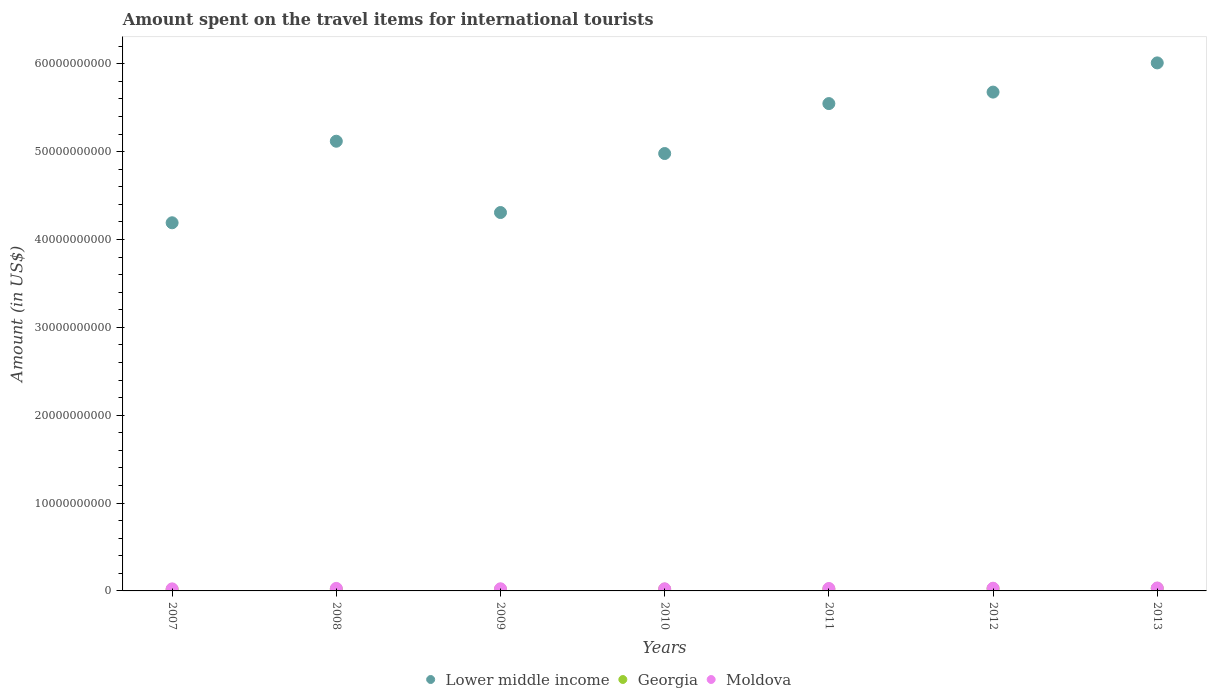How many different coloured dotlines are there?
Provide a short and direct response. 3. What is the amount spent on the travel items for international tourists in Moldova in 2013?
Offer a terse response. 3.34e+08. Across all years, what is the maximum amount spent on the travel items for international tourists in Lower middle income?
Give a very brief answer. 6.01e+1. Across all years, what is the minimum amount spent on the travel items for international tourists in Georgia?
Your answer should be very brief. 1.76e+08. In which year was the amount spent on the travel items for international tourists in Georgia maximum?
Your answer should be compact. 2013. What is the total amount spent on the travel items for international tourists in Moldova in the graph?
Provide a succinct answer. 1.92e+09. What is the difference between the amount spent on the travel items for international tourists in Lower middle income in 2008 and that in 2012?
Make the answer very short. -5.59e+09. What is the difference between the amount spent on the travel items for international tourists in Lower middle income in 2013 and the amount spent on the travel items for international tourists in Moldova in 2012?
Offer a very short reply. 5.98e+1. What is the average amount spent on the travel items for international tourists in Lower middle income per year?
Provide a succinct answer. 5.12e+1. In the year 2008, what is the difference between the amount spent on the travel items for international tourists in Lower middle income and amount spent on the travel items for international tourists in Moldova?
Keep it short and to the point. 5.09e+1. In how many years, is the amount spent on the travel items for international tourists in Georgia greater than 10000000000 US$?
Give a very brief answer. 0. What is the ratio of the amount spent on the travel items for international tourists in Lower middle income in 2009 to that in 2012?
Your answer should be very brief. 0.76. Is the amount spent on the travel items for international tourists in Moldova in 2010 less than that in 2012?
Your response must be concise. Yes. What is the difference between the highest and the second highest amount spent on the travel items for international tourists in Georgia?
Your response must be concise. 3.80e+07. What is the difference between the highest and the lowest amount spent on the travel items for international tourists in Moldova?
Provide a short and direct response. 1.01e+08. In how many years, is the amount spent on the travel items for international tourists in Lower middle income greater than the average amount spent on the travel items for international tourists in Lower middle income taken over all years?
Provide a succinct answer. 4. Is the sum of the amount spent on the travel items for international tourists in Georgia in 2010 and 2012 greater than the maximum amount spent on the travel items for international tourists in Moldova across all years?
Offer a very short reply. Yes. Is it the case that in every year, the sum of the amount spent on the travel items for international tourists in Georgia and amount spent on the travel items for international tourists in Lower middle income  is greater than the amount spent on the travel items for international tourists in Moldova?
Your answer should be compact. Yes. Are the values on the major ticks of Y-axis written in scientific E-notation?
Keep it short and to the point. No. Does the graph contain any zero values?
Provide a short and direct response. No. Where does the legend appear in the graph?
Your answer should be very brief. Bottom center. What is the title of the graph?
Keep it short and to the point. Amount spent on the travel items for international tourists. Does "Bahrain" appear as one of the legend labels in the graph?
Ensure brevity in your answer.  No. What is the label or title of the Y-axis?
Offer a terse response. Amount (in US$). What is the Amount (in US$) of Lower middle income in 2007?
Your answer should be compact. 4.19e+1. What is the Amount (in US$) of Georgia in 2007?
Your answer should be compact. 1.76e+08. What is the Amount (in US$) of Moldova in 2007?
Offer a terse response. 2.33e+08. What is the Amount (in US$) in Lower middle income in 2008?
Make the answer very short. 5.12e+1. What is the Amount (in US$) in Georgia in 2008?
Provide a short and direct response. 2.03e+08. What is the Amount (in US$) in Moldova in 2008?
Provide a succinct answer. 2.88e+08. What is the Amount (in US$) of Lower middle income in 2009?
Your answer should be very brief. 4.31e+1. What is the Amount (in US$) of Georgia in 2009?
Provide a short and direct response. 1.81e+08. What is the Amount (in US$) of Moldova in 2009?
Your answer should be very brief. 2.43e+08. What is the Amount (in US$) of Lower middle income in 2010?
Provide a short and direct response. 4.98e+1. What is the Amount (in US$) in Georgia in 2010?
Ensure brevity in your answer.  1.99e+08. What is the Amount (in US$) in Moldova in 2010?
Your response must be concise. 2.41e+08. What is the Amount (in US$) in Lower middle income in 2011?
Your answer should be compact. 5.55e+1. What is the Amount (in US$) in Georgia in 2011?
Ensure brevity in your answer.  2.13e+08. What is the Amount (in US$) of Moldova in 2011?
Offer a very short reply. 2.77e+08. What is the Amount (in US$) of Lower middle income in 2012?
Your response must be concise. 5.68e+1. What is the Amount (in US$) of Georgia in 2012?
Keep it short and to the point. 2.56e+08. What is the Amount (in US$) of Moldova in 2012?
Offer a terse response. 3.08e+08. What is the Amount (in US$) in Lower middle income in 2013?
Give a very brief answer. 6.01e+1. What is the Amount (in US$) of Georgia in 2013?
Provide a short and direct response. 2.94e+08. What is the Amount (in US$) in Moldova in 2013?
Offer a terse response. 3.34e+08. Across all years, what is the maximum Amount (in US$) in Lower middle income?
Your response must be concise. 6.01e+1. Across all years, what is the maximum Amount (in US$) in Georgia?
Provide a short and direct response. 2.94e+08. Across all years, what is the maximum Amount (in US$) in Moldova?
Offer a very short reply. 3.34e+08. Across all years, what is the minimum Amount (in US$) of Lower middle income?
Your response must be concise. 4.19e+1. Across all years, what is the minimum Amount (in US$) of Georgia?
Make the answer very short. 1.76e+08. Across all years, what is the minimum Amount (in US$) in Moldova?
Provide a short and direct response. 2.33e+08. What is the total Amount (in US$) in Lower middle income in the graph?
Your answer should be compact. 3.58e+11. What is the total Amount (in US$) in Georgia in the graph?
Provide a succinct answer. 1.52e+09. What is the total Amount (in US$) in Moldova in the graph?
Give a very brief answer. 1.92e+09. What is the difference between the Amount (in US$) of Lower middle income in 2007 and that in 2008?
Your answer should be very brief. -9.28e+09. What is the difference between the Amount (in US$) of Georgia in 2007 and that in 2008?
Offer a terse response. -2.70e+07. What is the difference between the Amount (in US$) in Moldova in 2007 and that in 2008?
Give a very brief answer. -5.50e+07. What is the difference between the Amount (in US$) of Lower middle income in 2007 and that in 2009?
Offer a very short reply. -1.17e+09. What is the difference between the Amount (in US$) of Georgia in 2007 and that in 2009?
Offer a terse response. -5.00e+06. What is the difference between the Amount (in US$) in Moldova in 2007 and that in 2009?
Your answer should be compact. -1.00e+07. What is the difference between the Amount (in US$) of Lower middle income in 2007 and that in 2010?
Your response must be concise. -7.88e+09. What is the difference between the Amount (in US$) of Georgia in 2007 and that in 2010?
Offer a terse response. -2.30e+07. What is the difference between the Amount (in US$) in Moldova in 2007 and that in 2010?
Provide a short and direct response. -8.00e+06. What is the difference between the Amount (in US$) of Lower middle income in 2007 and that in 2011?
Keep it short and to the point. -1.36e+1. What is the difference between the Amount (in US$) in Georgia in 2007 and that in 2011?
Keep it short and to the point. -3.70e+07. What is the difference between the Amount (in US$) in Moldova in 2007 and that in 2011?
Your answer should be compact. -4.40e+07. What is the difference between the Amount (in US$) in Lower middle income in 2007 and that in 2012?
Make the answer very short. -1.49e+1. What is the difference between the Amount (in US$) in Georgia in 2007 and that in 2012?
Your response must be concise. -8.00e+07. What is the difference between the Amount (in US$) in Moldova in 2007 and that in 2012?
Offer a very short reply. -7.50e+07. What is the difference between the Amount (in US$) in Lower middle income in 2007 and that in 2013?
Provide a succinct answer. -1.82e+1. What is the difference between the Amount (in US$) of Georgia in 2007 and that in 2013?
Offer a very short reply. -1.18e+08. What is the difference between the Amount (in US$) in Moldova in 2007 and that in 2013?
Keep it short and to the point. -1.01e+08. What is the difference between the Amount (in US$) in Lower middle income in 2008 and that in 2009?
Make the answer very short. 8.12e+09. What is the difference between the Amount (in US$) of Georgia in 2008 and that in 2009?
Give a very brief answer. 2.20e+07. What is the difference between the Amount (in US$) in Moldova in 2008 and that in 2009?
Ensure brevity in your answer.  4.50e+07. What is the difference between the Amount (in US$) of Lower middle income in 2008 and that in 2010?
Offer a terse response. 1.40e+09. What is the difference between the Amount (in US$) of Moldova in 2008 and that in 2010?
Keep it short and to the point. 4.70e+07. What is the difference between the Amount (in US$) of Lower middle income in 2008 and that in 2011?
Your answer should be very brief. -4.28e+09. What is the difference between the Amount (in US$) of Georgia in 2008 and that in 2011?
Your response must be concise. -1.00e+07. What is the difference between the Amount (in US$) in Moldova in 2008 and that in 2011?
Your answer should be compact. 1.10e+07. What is the difference between the Amount (in US$) in Lower middle income in 2008 and that in 2012?
Your answer should be compact. -5.59e+09. What is the difference between the Amount (in US$) in Georgia in 2008 and that in 2012?
Your answer should be compact. -5.30e+07. What is the difference between the Amount (in US$) of Moldova in 2008 and that in 2012?
Your answer should be compact. -2.00e+07. What is the difference between the Amount (in US$) of Lower middle income in 2008 and that in 2013?
Ensure brevity in your answer.  -8.91e+09. What is the difference between the Amount (in US$) of Georgia in 2008 and that in 2013?
Your response must be concise. -9.10e+07. What is the difference between the Amount (in US$) of Moldova in 2008 and that in 2013?
Make the answer very short. -4.60e+07. What is the difference between the Amount (in US$) of Lower middle income in 2009 and that in 2010?
Give a very brief answer. -6.72e+09. What is the difference between the Amount (in US$) of Georgia in 2009 and that in 2010?
Your answer should be compact. -1.80e+07. What is the difference between the Amount (in US$) in Moldova in 2009 and that in 2010?
Provide a succinct answer. 2.00e+06. What is the difference between the Amount (in US$) in Lower middle income in 2009 and that in 2011?
Provide a short and direct response. -1.24e+1. What is the difference between the Amount (in US$) of Georgia in 2009 and that in 2011?
Make the answer very short. -3.20e+07. What is the difference between the Amount (in US$) of Moldova in 2009 and that in 2011?
Your answer should be very brief. -3.40e+07. What is the difference between the Amount (in US$) in Lower middle income in 2009 and that in 2012?
Provide a succinct answer. -1.37e+1. What is the difference between the Amount (in US$) in Georgia in 2009 and that in 2012?
Your answer should be compact. -7.50e+07. What is the difference between the Amount (in US$) in Moldova in 2009 and that in 2012?
Offer a terse response. -6.50e+07. What is the difference between the Amount (in US$) of Lower middle income in 2009 and that in 2013?
Ensure brevity in your answer.  -1.70e+1. What is the difference between the Amount (in US$) of Georgia in 2009 and that in 2013?
Give a very brief answer. -1.13e+08. What is the difference between the Amount (in US$) in Moldova in 2009 and that in 2013?
Your answer should be compact. -9.10e+07. What is the difference between the Amount (in US$) in Lower middle income in 2010 and that in 2011?
Offer a terse response. -5.68e+09. What is the difference between the Amount (in US$) in Georgia in 2010 and that in 2011?
Offer a very short reply. -1.40e+07. What is the difference between the Amount (in US$) in Moldova in 2010 and that in 2011?
Your answer should be compact. -3.60e+07. What is the difference between the Amount (in US$) of Lower middle income in 2010 and that in 2012?
Offer a terse response. -6.99e+09. What is the difference between the Amount (in US$) in Georgia in 2010 and that in 2012?
Offer a terse response. -5.70e+07. What is the difference between the Amount (in US$) of Moldova in 2010 and that in 2012?
Ensure brevity in your answer.  -6.70e+07. What is the difference between the Amount (in US$) in Lower middle income in 2010 and that in 2013?
Your answer should be very brief. -1.03e+1. What is the difference between the Amount (in US$) of Georgia in 2010 and that in 2013?
Keep it short and to the point. -9.50e+07. What is the difference between the Amount (in US$) in Moldova in 2010 and that in 2013?
Your answer should be very brief. -9.30e+07. What is the difference between the Amount (in US$) in Lower middle income in 2011 and that in 2012?
Your response must be concise. -1.31e+09. What is the difference between the Amount (in US$) in Georgia in 2011 and that in 2012?
Your answer should be very brief. -4.30e+07. What is the difference between the Amount (in US$) of Moldova in 2011 and that in 2012?
Make the answer very short. -3.10e+07. What is the difference between the Amount (in US$) in Lower middle income in 2011 and that in 2013?
Offer a very short reply. -4.63e+09. What is the difference between the Amount (in US$) of Georgia in 2011 and that in 2013?
Make the answer very short. -8.10e+07. What is the difference between the Amount (in US$) in Moldova in 2011 and that in 2013?
Offer a very short reply. -5.70e+07. What is the difference between the Amount (in US$) in Lower middle income in 2012 and that in 2013?
Your response must be concise. -3.32e+09. What is the difference between the Amount (in US$) of Georgia in 2012 and that in 2013?
Give a very brief answer. -3.80e+07. What is the difference between the Amount (in US$) of Moldova in 2012 and that in 2013?
Your answer should be very brief. -2.60e+07. What is the difference between the Amount (in US$) of Lower middle income in 2007 and the Amount (in US$) of Georgia in 2008?
Ensure brevity in your answer.  4.17e+1. What is the difference between the Amount (in US$) of Lower middle income in 2007 and the Amount (in US$) of Moldova in 2008?
Ensure brevity in your answer.  4.16e+1. What is the difference between the Amount (in US$) of Georgia in 2007 and the Amount (in US$) of Moldova in 2008?
Give a very brief answer. -1.12e+08. What is the difference between the Amount (in US$) in Lower middle income in 2007 and the Amount (in US$) in Georgia in 2009?
Keep it short and to the point. 4.17e+1. What is the difference between the Amount (in US$) of Lower middle income in 2007 and the Amount (in US$) of Moldova in 2009?
Your answer should be very brief. 4.17e+1. What is the difference between the Amount (in US$) in Georgia in 2007 and the Amount (in US$) in Moldova in 2009?
Ensure brevity in your answer.  -6.70e+07. What is the difference between the Amount (in US$) in Lower middle income in 2007 and the Amount (in US$) in Georgia in 2010?
Keep it short and to the point. 4.17e+1. What is the difference between the Amount (in US$) of Lower middle income in 2007 and the Amount (in US$) of Moldova in 2010?
Keep it short and to the point. 4.17e+1. What is the difference between the Amount (in US$) in Georgia in 2007 and the Amount (in US$) in Moldova in 2010?
Your answer should be very brief. -6.50e+07. What is the difference between the Amount (in US$) in Lower middle income in 2007 and the Amount (in US$) in Georgia in 2011?
Make the answer very short. 4.17e+1. What is the difference between the Amount (in US$) in Lower middle income in 2007 and the Amount (in US$) in Moldova in 2011?
Provide a short and direct response. 4.16e+1. What is the difference between the Amount (in US$) of Georgia in 2007 and the Amount (in US$) of Moldova in 2011?
Provide a succinct answer. -1.01e+08. What is the difference between the Amount (in US$) in Lower middle income in 2007 and the Amount (in US$) in Georgia in 2012?
Provide a succinct answer. 4.16e+1. What is the difference between the Amount (in US$) of Lower middle income in 2007 and the Amount (in US$) of Moldova in 2012?
Ensure brevity in your answer.  4.16e+1. What is the difference between the Amount (in US$) of Georgia in 2007 and the Amount (in US$) of Moldova in 2012?
Offer a terse response. -1.32e+08. What is the difference between the Amount (in US$) of Lower middle income in 2007 and the Amount (in US$) of Georgia in 2013?
Your answer should be very brief. 4.16e+1. What is the difference between the Amount (in US$) of Lower middle income in 2007 and the Amount (in US$) of Moldova in 2013?
Your answer should be compact. 4.16e+1. What is the difference between the Amount (in US$) in Georgia in 2007 and the Amount (in US$) in Moldova in 2013?
Give a very brief answer. -1.58e+08. What is the difference between the Amount (in US$) in Lower middle income in 2008 and the Amount (in US$) in Georgia in 2009?
Your answer should be compact. 5.10e+1. What is the difference between the Amount (in US$) of Lower middle income in 2008 and the Amount (in US$) of Moldova in 2009?
Make the answer very short. 5.09e+1. What is the difference between the Amount (in US$) of Georgia in 2008 and the Amount (in US$) of Moldova in 2009?
Keep it short and to the point. -4.00e+07. What is the difference between the Amount (in US$) in Lower middle income in 2008 and the Amount (in US$) in Georgia in 2010?
Your response must be concise. 5.10e+1. What is the difference between the Amount (in US$) in Lower middle income in 2008 and the Amount (in US$) in Moldova in 2010?
Your answer should be very brief. 5.09e+1. What is the difference between the Amount (in US$) of Georgia in 2008 and the Amount (in US$) of Moldova in 2010?
Ensure brevity in your answer.  -3.80e+07. What is the difference between the Amount (in US$) of Lower middle income in 2008 and the Amount (in US$) of Georgia in 2011?
Ensure brevity in your answer.  5.10e+1. What is the difference between the Amount (in US$) of Lower middle income in 2008 and the Amount (in US$) of Moldova in 2011?
Provide a short and direct response. 5.09e+1. What is the difference between the Amount (in US$) of Georgia in 2008 and the Amount (in US$) of Moldova in 2011?
Keep it short and to the point. -7.40e+07. What is the difference between the Amount (in US$) in Lower middle income in 2008 and the Amount (in US$) in Georgia in 2012?
Make the answer very short. 5.09e+1. What is the difference between the Amount (in US$) of Lower middle income in 2008 and the Amount (in US$) of Moldova in 2012?
Offer a very short reply. 5.09e+1. What is the difference between the Amount (in US$) of Georgia in 2008 and the Amount (in US$) of Moldova in 2012?
Give a very brief answer. -1.05e+08. What is the difference between the Amount (in US$) of Lower middle income in 2008 and the Amount (in US$) of Georgia in 2013?
Your answer should be compact. 5.09e+1. What is the difference between the Amount (in US$) in Lower middle income in 2008 and the Amount (in US$) in Moldova in 2013?
Provide a succinct answer. 5.08e+1. What is the difference between the Amount (in US$) of Georgia in 2008 and the Amount (in US$) of Moldova in 2013?
Offer a terse response. -1.31e+08. What is the difference between the Amount (in US$) of Lower middle income in 2009 and the Amount (in US$) of Georgia in 2010?
Provide a short and direct response. 4.29e+1. What is the difference between the Amount (in US$) of Lower middle income in 2009 and the Amount (in US$) of Moldova in 2010?
Offer a very short reply. 4.28e+1. What is the difference between the Amount (in US$) in Georgia in 2009 and the Amount (in US$) in Moldova in 2010?
Give a very brief answer. -6.00e+07. What is the difference between the Amount (in US$) in Lower middle income in 2009 and the Amount (in US$) in Georgia in 2011?
Give a very brief answer. 4.29e+1. What is the difference between the Amount (in US$) in Lower middle income in 2009 and the Amount (in US$) in Moldova in 2011?
Provide a short and direct response. 4.28e+1. What is the difference between the Amount (in US$) in Georgia in 2009 and the Amount (in US$) in Moldova in 2011?
Your answer should be very brief. -9.60e+07. What is the difference between the Amount (in US$) in Lower middle income in 2009 and the Amount (in US$) in Georgia in 2012?
Your answer should be very brief. 4.28e+1. What is the difference between the Amount (in US$) of Lower middle income in 2009 and the Amount (in US$) of Moldova in 2012?
Keep it short and to the point. 4.28e+1. What is the difference between the Amount (in US$) of Georgia in 2009 and the Amount (in US$) of Moldova in 2012?
Provide a succinct answer. -1.27e+08. What is the difference between the Amount (in US$) of Lower middle income in 2009 and the Amount (in US$) of Georgia in 2013?
Provide a short and direct response. 4.28e+1. What is the difference between the Amount (in US$) of Lower middle income in 2009 and the Amount (in US$) of Moldova in 2013?
Your response must be concise. 4.27e+1. What is the difference between the Amount (in US$) in Georgia in 2009 and the Amount (in US$) in Moldova in 2013?
Ensure brevity in your answer.  -1.53e+08. What is the difference between the Amount (in US$) in Lower middle income in 2010 and the Amount (in US$) in Georgia in 2011?
Your answer should be very brief. 4.96e+1. What is the difference between the Amount (in US$) of Lower middle income in 2010 and the Amount (in US$) of Moldova in 2011?
Provide a succinct answer. 4.95e+1. What is the difference between the Amount (in US$) of Georgia in 2010 and the Amount (in US$) of Moldova in 2011?
Provide a succinct answer. -7.80e+07. What is the difference between the Amount (in US$) of Lower middle income in 2010 and the Amount (in US$) of Georgia in 2012?
Offer a terse response. 4.95e+1. What is the difference between the Amount (in US$) in Lower middle income in 2010 and the Amount (in US$) in Moldova in 2012?
Provide a succinct answer. 4.95e+1. What is the difference between the Amount (in US$) of Georgia in 2010 and the Amount (in US$) of Moldova in 2012?
Provide a short and direct response. -1.09e+08. What is the difference between the Amount (in US$) in Lower middle income in 2010 and the Amount (in US$) in Georgia in 2013?
Your answer should be very brief. 4.95e+1. What is the difference between the Amount (in US$) in Lower middle income in 2010 and the Amount (in US$) in Moldova in 2013?
Offer a very short reply. 4.94e+1. What is the difference between the Amount (in US$) of Georgia in 2010 and the Amount (in US$) of Moldova in 2013?
Offer a very short reply. -1.35e+08. What is the difference between the Amount (in US$) of Lower middle income in 2011 and the Amount (in US$) of Georgia in 2012?
Your answer should be compact. 5.52e+1. What is the difference between the Amount (in US$) of Lower middle income in 2011 and the Amount (in US$) of Moldova in 2012?
Ensure brevity in your answer.  5.52e+1. What is the difference between the Amount (in US$) in Georgia in 2011 and the Amount (in US$) in Moldova in 2012?
Provide a short and direct response. -9.50e+07. What is the difference between the Amount (in US$) of Lower middle income in 2011 and the Amount (in US$) of Georgia in 2013?
Offer a terse response. 5.52e+1. What is the difference between the Amount (in US$) in Lower middle income in 2011 and the Amount (in US$) in Moldova in 2013?
Offer a very short reply. 5.51e+1. What is the difference between the Amount (in US$) of Georgia in 2011 and the Amount (in US$) of Moldova in 2013?
Make the answer very short. -1.21e+08. What is the difference between the Amount (in US$) of Lower middle income in 2012 and the Amount (in US$) of Georgia in 2013?
Your answer should be compact. 5.65e+1. What is the difference between the Amount (in US$) of Lower middle income in 2012 and the Amount (in US$) of Moldova in 2013?
Provide a succinct answer. 5.64e+1. What is the difference between the Amount (in US$) in Georgia in 2012 and the Amount (in US$) in Moldova in 2013?
Your response must be concise. -7.80e+07. What is the average Amount (in US$) of Lower middle income per year?
Your answer should be very brief. 5.12e+1. What is the average Amount (in US$) of Georgia per year?
Offer a very short reply. 2.17e+08. What is the average Amount (in US$) of Moldova per year?
Give a very brief answer. 2.75e+08. In the year 2007, what is the difference between the Amount (in US$) in Lower middle income and Amount (in US$) in Georgia?
Provide a short and direct response. 4.17e+1. In the year 2007, what is the difference between the Amount (in US$) of Lower middle income and Amount (in US$) of Moldova?
Your answer should be compact. 4.17e+1. In the year 2007, what is the difference between the Amount (in US$) of Georgia and Amount (in US$) of Moldova?
Offer a terse response. -5.70e+07. In the year 2008, what is the difference between the Amount (in US$) of Lower middle income and Amount (in US$) of Georgia?
Provide a succinct answer. 5.10e+1. In the year 2008, what is the difference between the Amount (in US$) of Lower middle income and Amount (in US$) of Moldova?
Provide a succinct answer. 5.09e+1. In the year 2008, what is the difference between the Amount (in US$) in Georgia and Amount (in US$) in Moldova?
Offer a terse response. -8.50e+07. In the year 2009, what is the difference between the Amount (in US$) of Lower middle income and Amount (in US$) of Georgia?
Your answer should be very brief. 4.29e+1. In the year 2009, what is the difference between the Amount (in US$) in Lower middle income and Amount (in US$) in Moldova?
Your response must be concise. 4.28e+1. In the year 2009, what is the difference between the Amount (in US$) of Georgia and Amount (in US$) of Moldova?
Provide a succinct answer. -6.20e+07. In the year 2010, what is the difference between the Amount (in US$) in Lower middle income and Amount (in US$) in Georgia?
Give a very brief answer. 4.96e+1. In the year 2010, what is the difference between the Amount (in US$) of Lower middle income and Amount (in US$) of Moldova?
Make the answer very short. 4.95e+1. In the year 2010, what is the difference between the Amount (in US$) of Georgia and Amount (in US$) of Moldova?
Your answer should be very brief. -4.20e+07. In the year 2011, what is the difference between the Amount (in US$) of Lower middle income and Amount (in US$) of Georgia?
Your answer should be very brief. 5.53e+1. In the year 2011, what is the difference between the Amount (in US$) of Lower middle income and Amount (in US$) of Moldova?
Make the answer very short. 5.52e+1. In the year 2011, what is the difference between the Amount (in US$) in Georgia and Amount (in US$) in Moldova?
Your answer should be very brief. -6.40e+07. In the year 2012, what is the difference between the Amount (in US$) of Lower middle income and Amount (in US$) of Georgia?
Your answer should be compact. 5.65e+1. In the year 2012, what is the difference between the Amount (in US$) of Lower middle income and Amount (in US$) of Moldova?
Make the answer very short. 5.65e+1. In the year 2012, what is the difference between the Amount (in US$) in Georgia and Amount (in US$) in Moldova?
Provide a succinct answer. -5.20e+07. In the year 2013, what is the difference between the Amount (in US$) in Lower middle income and Amount (in US$) in Georgia?
Ensure brevity in your answer.  5.98e+1. In the year 2013, what is the difference between the Amount (in US$) of Lower middle income and Amount (in US$) of Moldova?
Your response must be concise. 5.98e+1. In the year 2013, what is the difference between the Amount (in US$) in Georgia and Amount (in US$) in Moldova?
Offer a terse response. -4.00e+07. What is the ratio of the Amount (in US$) in Lower middle income in 2007 to that in 2008?
Offer a very short reply. 0.82. What is the ratio of the Amount (in US$) in Georgia in 2007 to that in 2008?
Provide a succinct answer. 0.87. What is the ratio of the Amount (in US$) in Moldova in 2007 to that in 2008?
Make the answer very short. 0.81. What is the ratio of the Amount (in US$) in Lower middle income in 2007 to that in 2009?
Provide a short and direct response. 0.97. What is the ratio of the Amount (in US$) in Georgia in 2007 to that in 2009?
Offer a very short reply. 0.97. What is the ratio of the Amount (in US$) of Moldova in 2007 to that in 2009?
Provide a short and direct response. 0.96. What is the ratio of the Amount (in US$) in Lower middle income in 2007 to that in 2010?
Your response must be concise. 0.84. What is the ratio of the Amount (in US$) in Georgia in 2007 to that in 2010?
Give a very brief answer. 0.88. What is the ratio of the Amount (in US$) in Moldova in 2007 to that in 2010?
Keep it short and to the point. 0.97. What is the ratio of the Amount (in US$) in Lower middle income in 2007 to that in 2011?
Make the answer very short. 0.76. What is the ratio of the Amount (in US$) of Georgia in 2007 to that in 2011?
Give a very brief answer. 0.83. What is the ratio of the Amount (in US$) of Moldova in 2007 to that in 2011?
Give a very brief answer. 0.84. What is the ratio of the Amount (in US$) in Lower middle income in 2007 to that in 2012?
Provide a short and direct response. 0.74. What is the ratio of the Amount (in US$) in Georgia in 2007 to that in 2012?
Keep it short and to the point. 0.69. What is the ratio of the Amount (in US$) in Moldova in 2007 to that in 2012?
Your response must be concise. 0.76. What is the ratio of the Amount (in US$) of Lower middle income in 2007 to that in 2013?
Your answer should be very brief. 0.7. What is the ratio of the Amount (in US$) of Georgia in 2007 to that in 2013?
Keep it short and to the point. 0.6. What is the ratio of the Amount (in US$) in Moldova in 2007 to that in 2013?
Ensure brevity in your answer.  0.7. What is the ratio of the Amount (in US$) of Lower middle income in 2008 to that in 2009?
Your answer should be very brief. 1.19. What is the ratio of the Amount (in US$) in Georgia in 2008 to that in 2009?
Ensure brevity in your answer.  1.12. What is the ratio of the Amount (in US$) of Moldova in 2008 to that in 2009?
Provide a succinct answer. 1.19. What is the ratio of the Amount (in US$) of Lower middle income in 2008 to that in 2010?
Give a very brief answer. 1.03. What is the ratio of the Amount (in US$) of Georgia in 2008 to that in 2010?
Offer a very short reply. 1.02. What is the ratio of the Amount (in US$) of Moldova in 2008 to that in 2010?
Offer a very short reply. 1.2. What is the ratio of the Amount (in US$) of Lower middle income in 2008 to that in 2011?
Make the answer very short. 0.92. What is the ratio of the Amount (in US$) of Georgia in 2008 to that in 2011?
Offer a very short reply. 0.95. What is the ratio of the Amount (in US$) of Moldova in 2008 to that in 2011?
Keep it short and to the point. 1.04. What is the ratio of the Amount (in US$) in Lower middle income in 2008 to that in 2012?
Provide a succinct answer. 0.9. What is the ratio of the Amount (in US$) of Georgia in 2008 to that in 2012?
Make the answer very short. 0.79. What is the ratio of the Amount (in US$) in Moldova in 2008 to that in 2012?
Your response must be concise. 0.94. What is the ratio of the Amount (in US$) of Lower middle income in 2008 to that in 2013?
Provide a short and direct response. 0.85. What is the ratio of the Amount (in US$) in Georgia in 2008 to that in 2013?
Make the answer very short. 0.69. What is the ratio of the Amount (in US$) in Moldova in 2008 to that in 2013?
Your response must be concise. 0.86. What is the ratio of the Amount (in US$) of Lower middle income in 2009 to that in 2010?
Your response must be concise. 0.87. What is the ratio of the Amount (in US$) in Georgia in 2009 to that in 2010?
Keep it short and to the point. 0.91. What is the ratio of the Amount (in US$) of Moldova in 2009 to that in 2010?
Make the answer very short. 1.01. What is the ratio of the Amount (in US$) of Lower middle income in 2009 to that in 2011?
Ensure brevity in your answer.  0.78. What is the ratio of the Amount (in US$) in Georgia in 2009 to that in 2011?
Your response must be concise. 0.85. What is the ratio of the Amount (in US$) in Moldova in 2009 to that in 2011?
Provide a short and direct response. 0.88. What is the ratio of the Amount (in US$) in Lower middle income in 2009 to that in 2012?
Your answer should be compact. 0.76. What is the ratio of the Amount (in US$) in Georgia in 2009 to that in 2012?
Keep it short and to the point. 0.71. What is the ratio of the Amount (in US$) of Moldova in 2009 to that in 2012?
Provide a succinct answer. 0.79. What is the ratio of the Amount (in US$) in Lower middle income in 2009 to that in 2013?
Ensure brevity in your answer.  0.72. What is the ratio of the Amount (in US$) in Georgia in 2009 to that in 2013?
Your answer should be compact. 0.62. What is the ratio of the Amount (in US$) in Moldova in 2009 to that in 2013?
Offer a very short reply. 0.73. What is the ratio of the Amount (in US$) in Lower middle income in 2010 to that in 2011?
Provide a succinct answer. 0.9. What is the ratio of the Amount (in US$) in Georgia in 2010 to that in 2011?
Provide a short and direct response. 0.93. What is the ratio of the Amount (in US$) of Moldova in 2010 to that in 2011?
Offer a very short reply. 0.87. What is the ratio of the Amount (in US$) in Lower middle income in 2010 to that in 2012?
Your answer should be compact. 0.88. What is the ratio of the Amount (in US$) of Georgia in 2010 to that in 2012?
Provide a short and direct response. 0.78. What is the ratio of the Amount (in US$) of Moldova in 2010 to that in 2012?
Your response must be concise. 0.78. What is the ratio of the Amount (in US$) of Lower middle income in 2010 to that in 2013?
Keep it short and to the point. 0.83. What is the ratio of the Amount (in US$) of Georgia in 2010 to that in 2013?
Give a very brief answer. 0.68. What is the ratio of the Amount (in US$) of Moldova in 2010 to that in 2013?
Provide a succinct answer. 0.72. What is the ratio of the Amount (in US$) of Lower middle income in 2011 to that in 2012?
Provide a short and direct response. 0.98. What is the ratio of the Amount (in US$) in Georgia in 2011 to that in 2012?
Your response must be concise. 0.83. What is the ratio of the Amount (in US$) of Moldova in 2011 to that in 2012?
Your answer should be very brief. 0.9. What is the ratio of the Amount (in US$) of Lower middle income in 2011 to that in 2013?
Give a very brief answer. 0.92. What is the ratio of the Amount (in US$) of Georgia in 2011 to that in 2013?
Provide a short and direct response. 0.72. What is the ratio of the Amount (in US$) of Moldova in 2011 to that in 2013?
Keep it short and to the point. 0.83. What is the ratio of the Amount (in US$) in Lower middle income in 2012 to that in 2013?
Make the answer very short. 0.94. What is the ratio of the Amount (in US$) of Georgia in 2012 to that in 2013?
Offer a very short reply. 0.87. What is the ratio of the Amount (in US$) in Moldova in 2012 to that in 2013?
Offer a terse response. 0.92. What is the difference between the highest and the second highest Amount (in US$) of Lower middle income?
Offer a terse response. 3.32e+09. What is the difference between the highest and the second highest Amount (in US$) of Georgia?
Keep it short and to the point. 3.80e+07. What is the difference between the highest and the second highest Amount (in US$) in Moldova?
Keep it short and to the point. 2.60e+07. What is the difference between the highest and the lowest Amount (in US$) of Lower middle income?
Make the answer very short. 1.82e+1. What is the difference between the highest and the lowest Amount (in US$) of Georgia?
Your answer should be very brief. 1.18e+08. What is the difference between the highest and the lowest Amount (in US$) of Moldova?
Provide a succinct answer. 1.01e+08. 